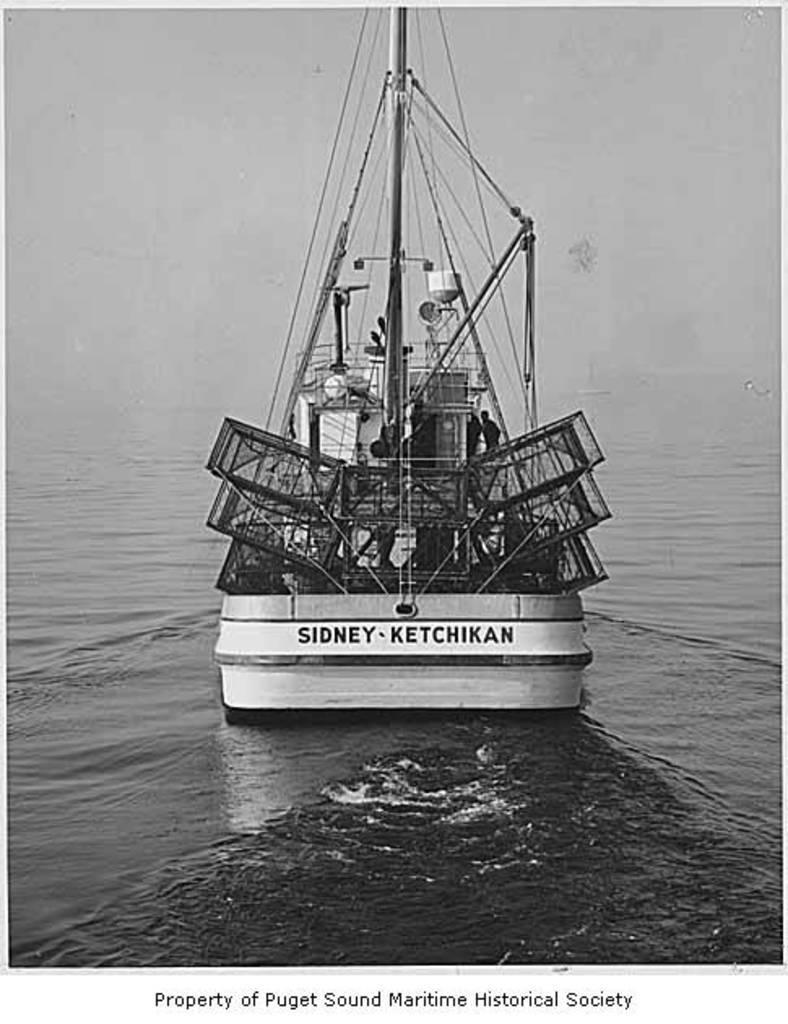Can you describe this image briefly? This picture is clicked outside. In the center we can see a boat in the water body and we can see the text on the boat and we can see the metal objects, persons and some other objects. At the bottom we can see the text on the image. 